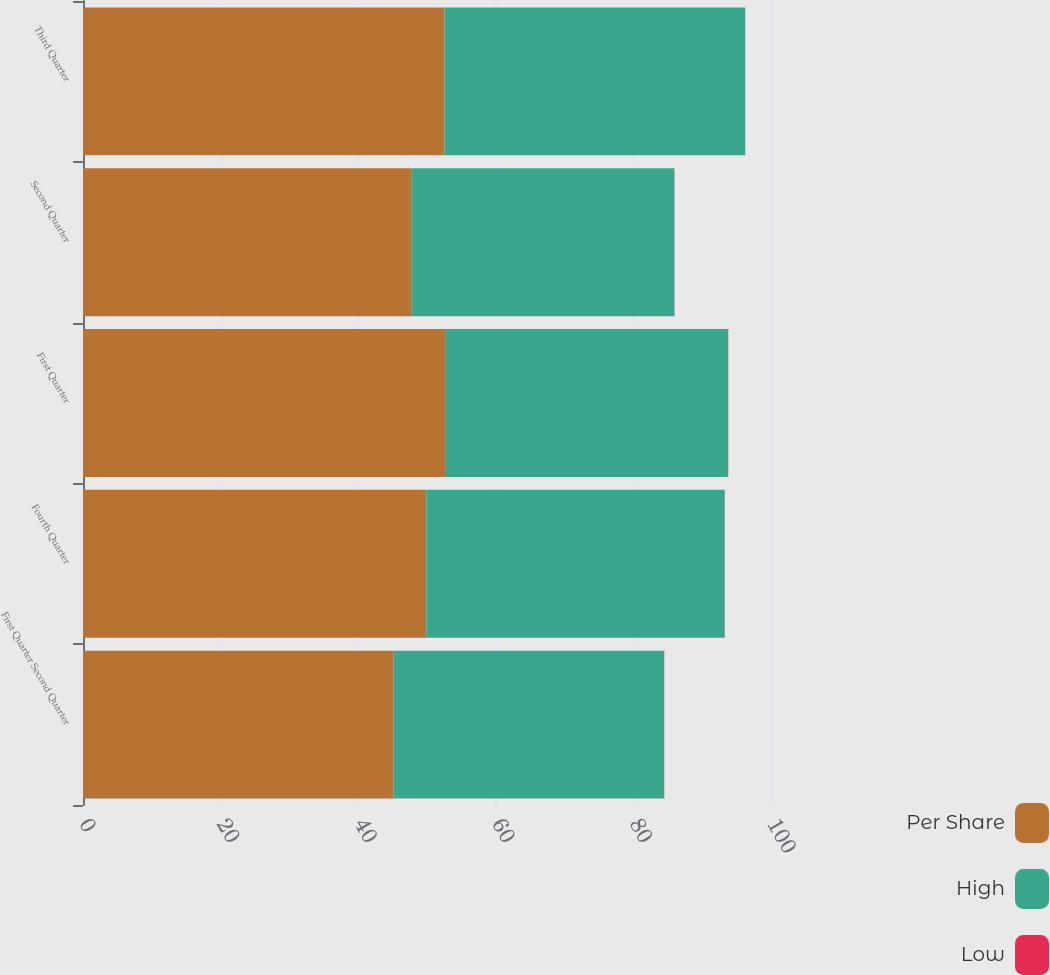<chart> <loc_0><loc_0><loc_500><loc_500><stacked_bar_chart><ecel><fcel>First Quarter Second Quarter<fcel>Fourth Quarter<fcel>First Quarter<fcel>Second Quarter<fcel>Third Quarter<nl><fcel>Per Share<fcel>45.1<fcel>49.9<fcel>52.75<fcel>47.7<fcel>52.55<nl><fcel>High<fcel>39.37<fcel>43.37<fcel>41.02<fcel>38.26<fcel>43.69<nl><fcel>Low<fcel>0.02<fcel>0.02<fcel>0.02<fcel>0.02<fcel>0.02<nl></chart> 